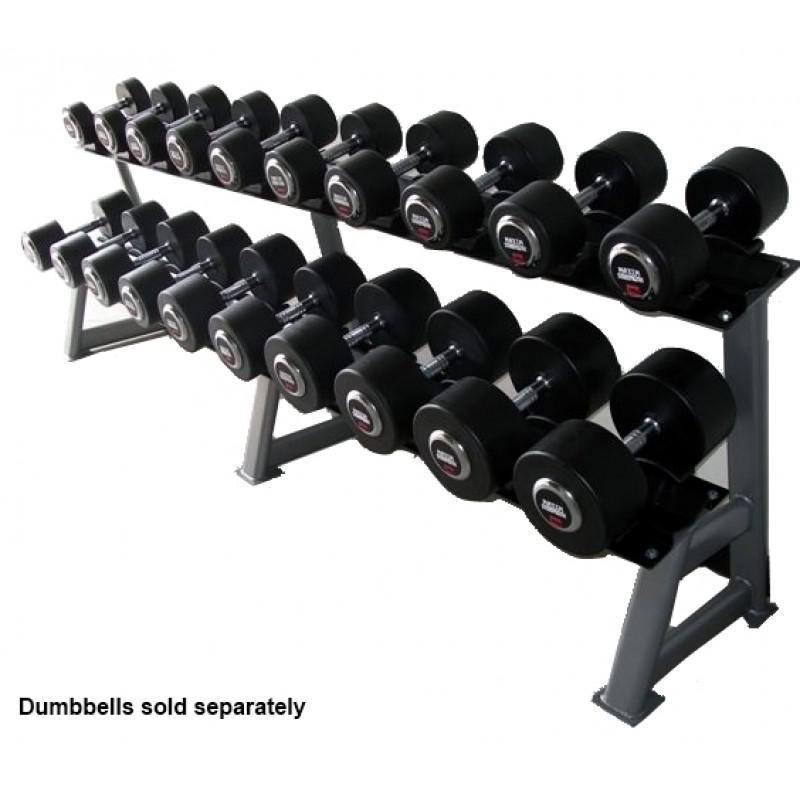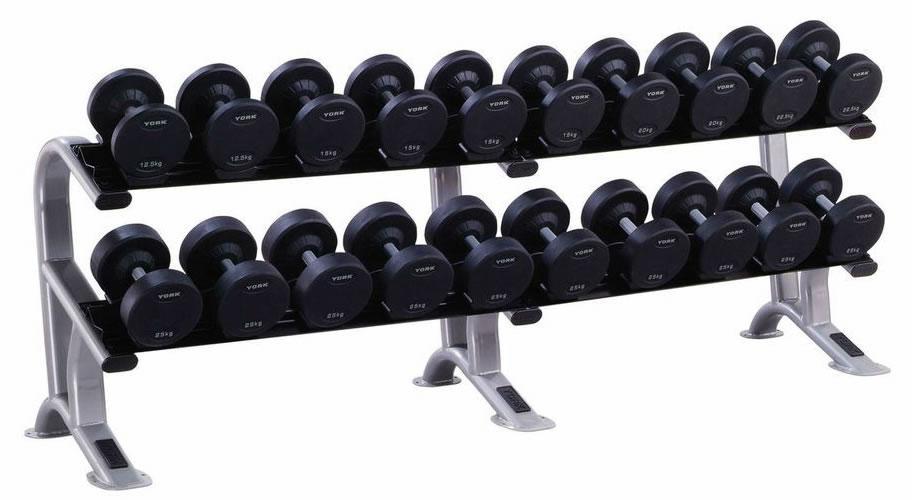The first image is the image on the left, the second image is the image on the right. For the images displayed, is the sentence "Right image shows a weight rack with exactly two horizontal rows of dumbbells." factually correct? Answer yes or no. Yes. The first image is the image on the left, the second image is the image on the right. For the images shown, is this caption "A white rack with three layers is in the left image." true? Answer yes or no. No. 